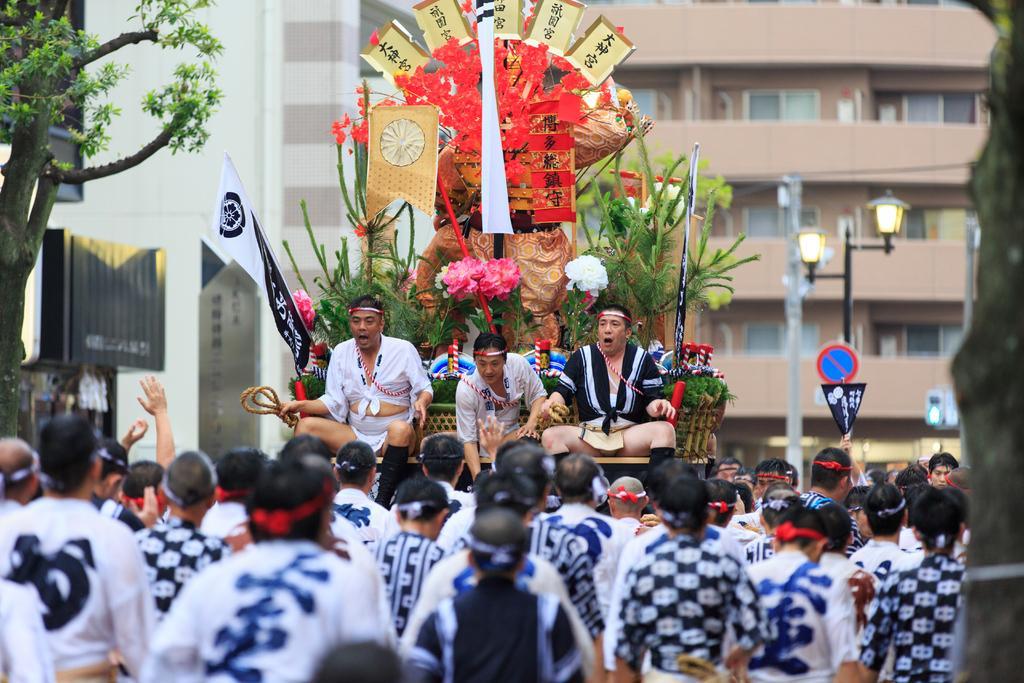Could you give a brief overview of what you see in this image? In this picture I can see few people are on the vehicle with some flowers, in front few people are standing and watching, behind there are some buildings and trees. 